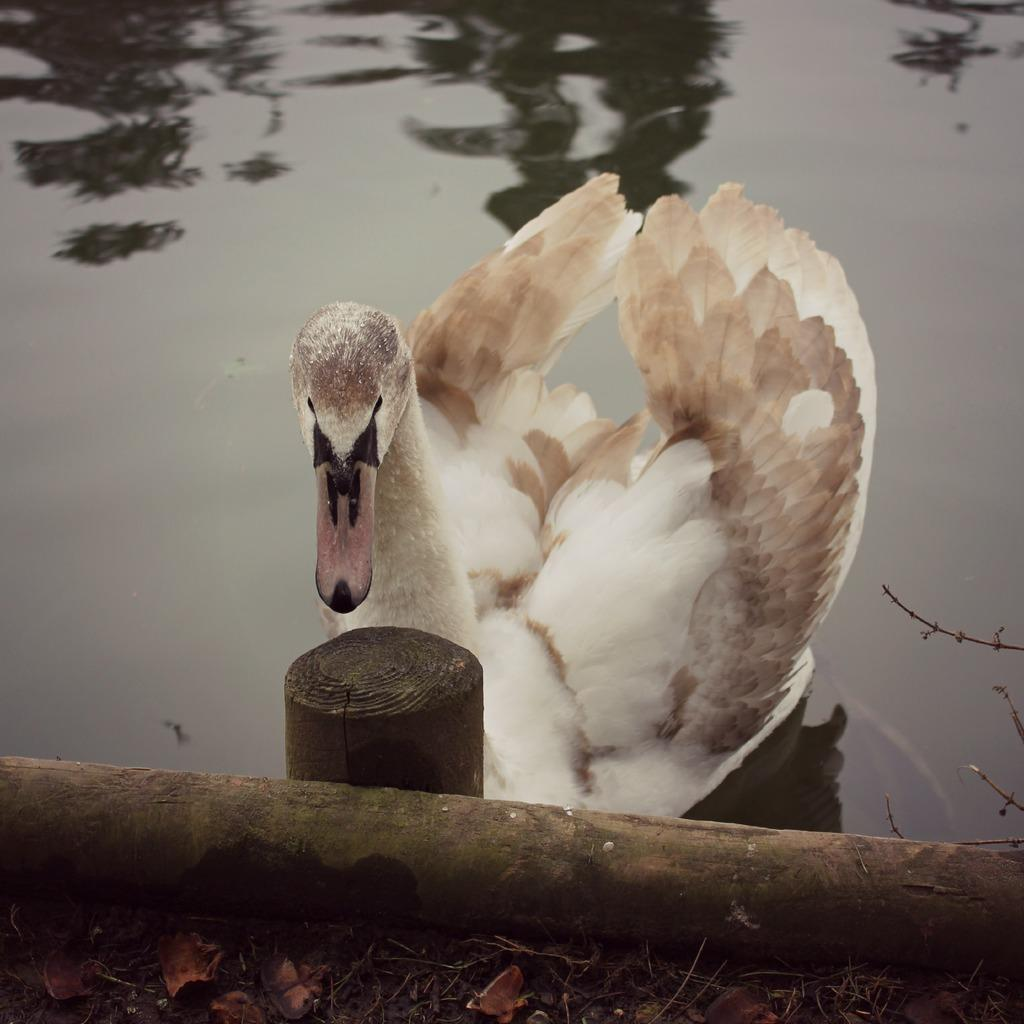What type of animal can be seen in the picture? There is a bird in the picture. Where is the bird located? The bird is on the water. What type of material can be seen in the picture? There are wooden objects in the picture. What type of plant material is present in the picture? Leaves are present in the picture. What type of brass instrument can be seen in the picture? There is no brass instrument present in the picture; it features a bird on the water, wooden objects, and leaves. Is there a bear visible in the picture? No, there is no bear present in the picture. 